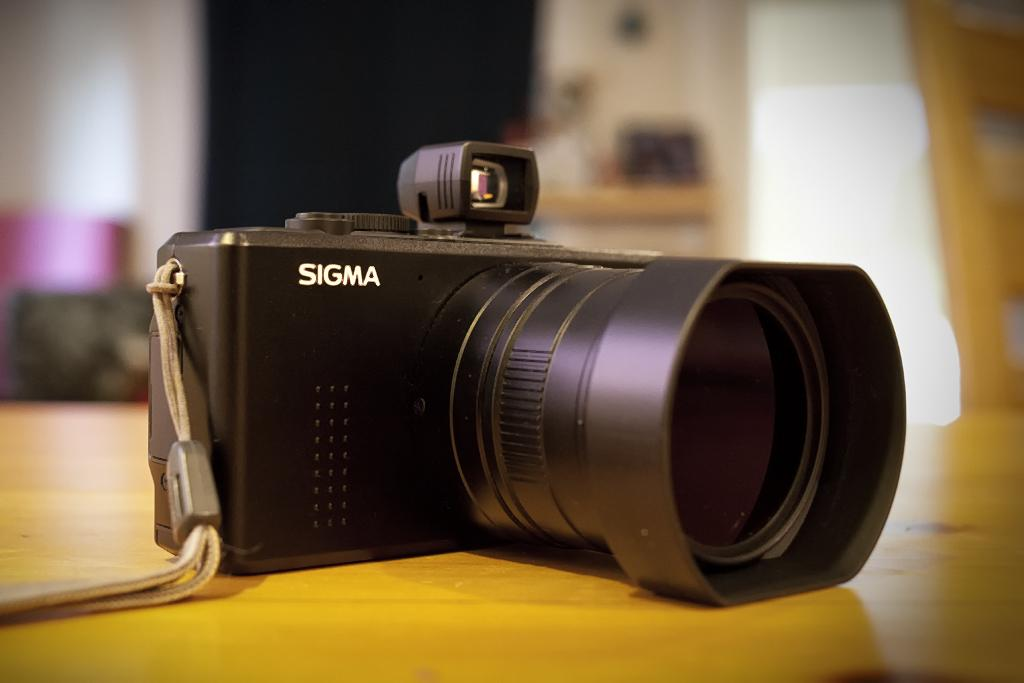What object is on the table in the image? There is a camera on the table in the image. What can be seen in the background of the image? There are objects in the background of the image. How is the background of the image depicted? The background of the image is blurred. Can you see any masks or badges in the image? There are no masks or badges present in the image. Is there an airport visible in the image? There is no airport depicted in the image. 